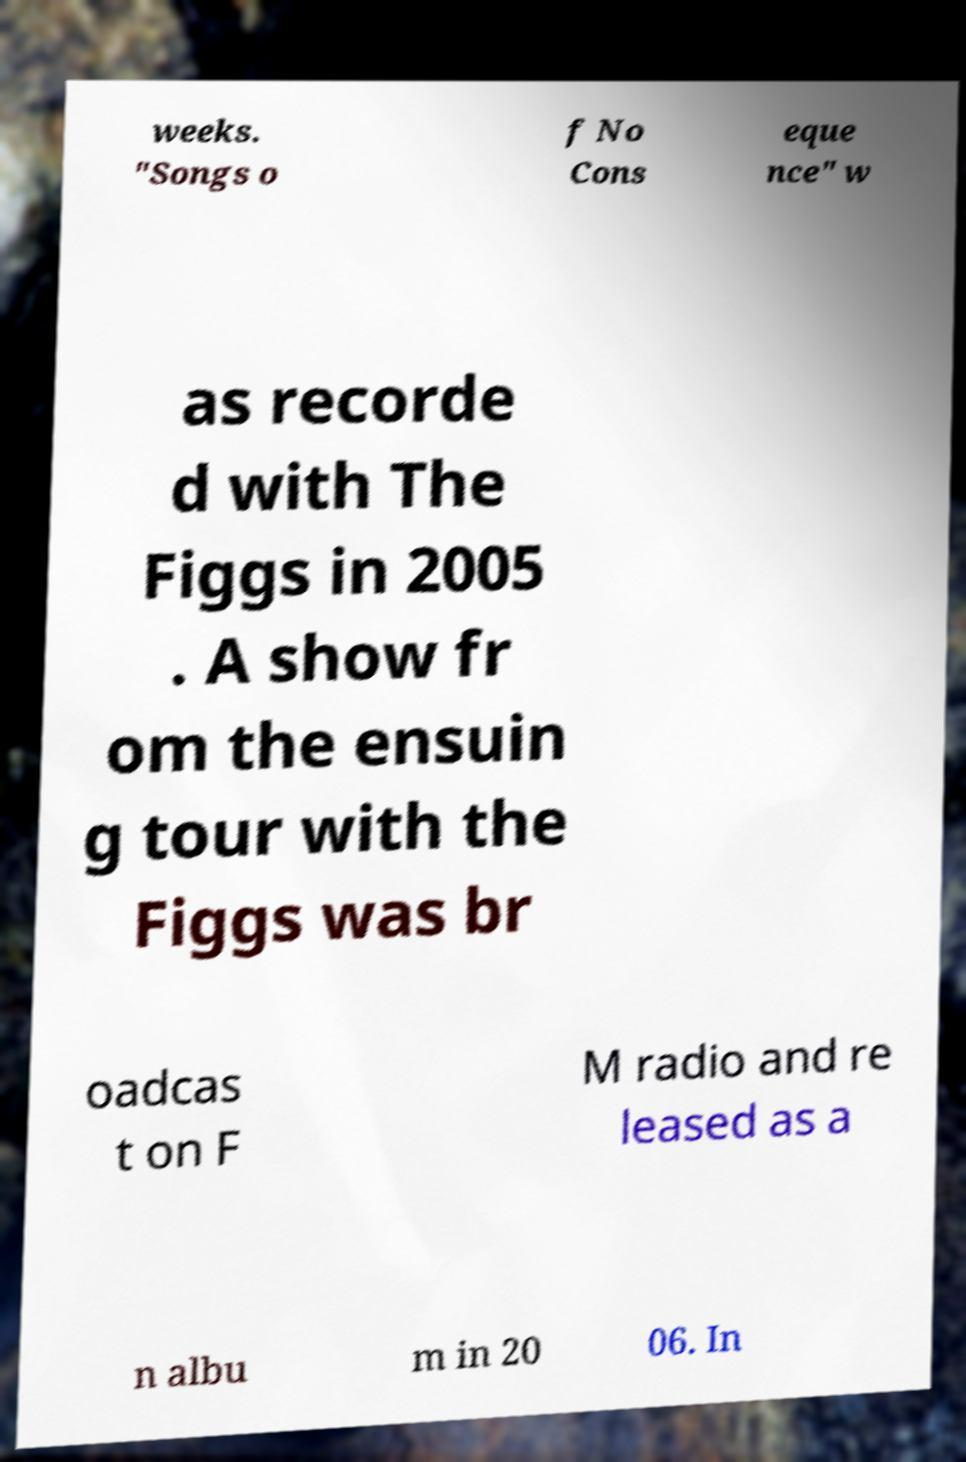Please identify and transcribe the text found in this image. weeks. "Songs o f No Cons eque nce" w as recorde d with The Figgs in 2005 . A show fr om the ensuin g tour with the Figgs was br oadcas t on F M radio and re leased as a n albu m in 20 06. In 